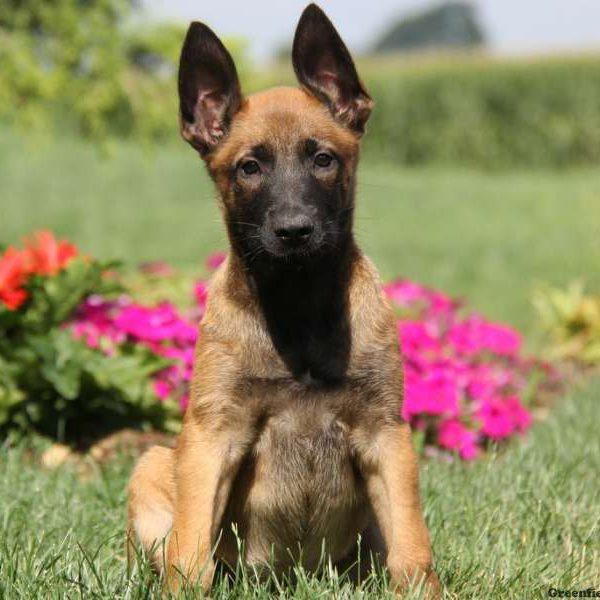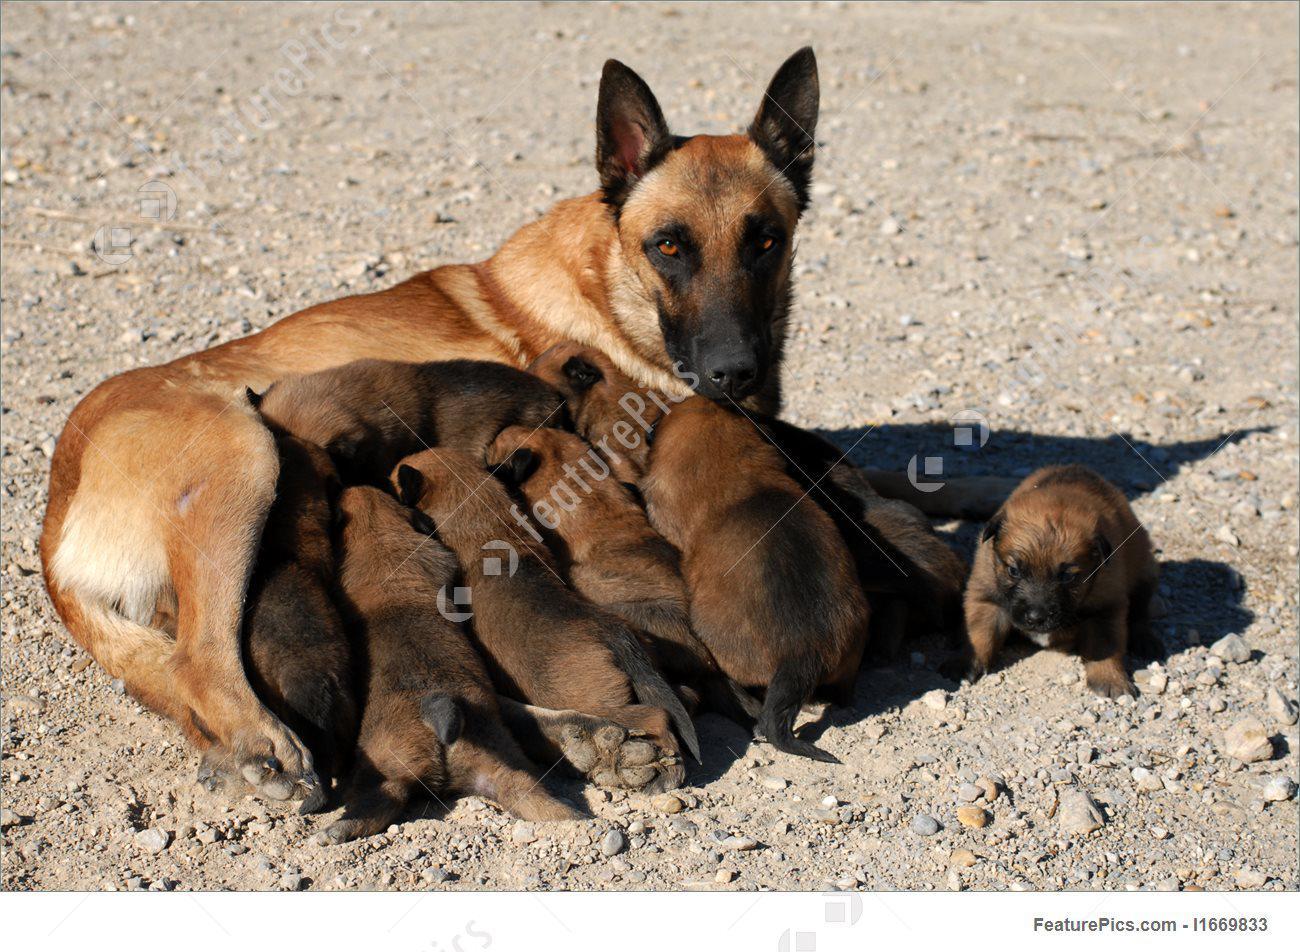The first image is the image on the left, the second image is the image on the right. For the images displayed, is the sentence "In one of the images there is a dog sitting and wear a harness with a leash attached." factually correct? Answer yes or no. No. The first image is the image on the left, the second image is the image on the right. Examine the images to the left and right. Is the description "An image shows a young dog wearing a black harness with a leash attached." accurate? Answer yes or no. No. 